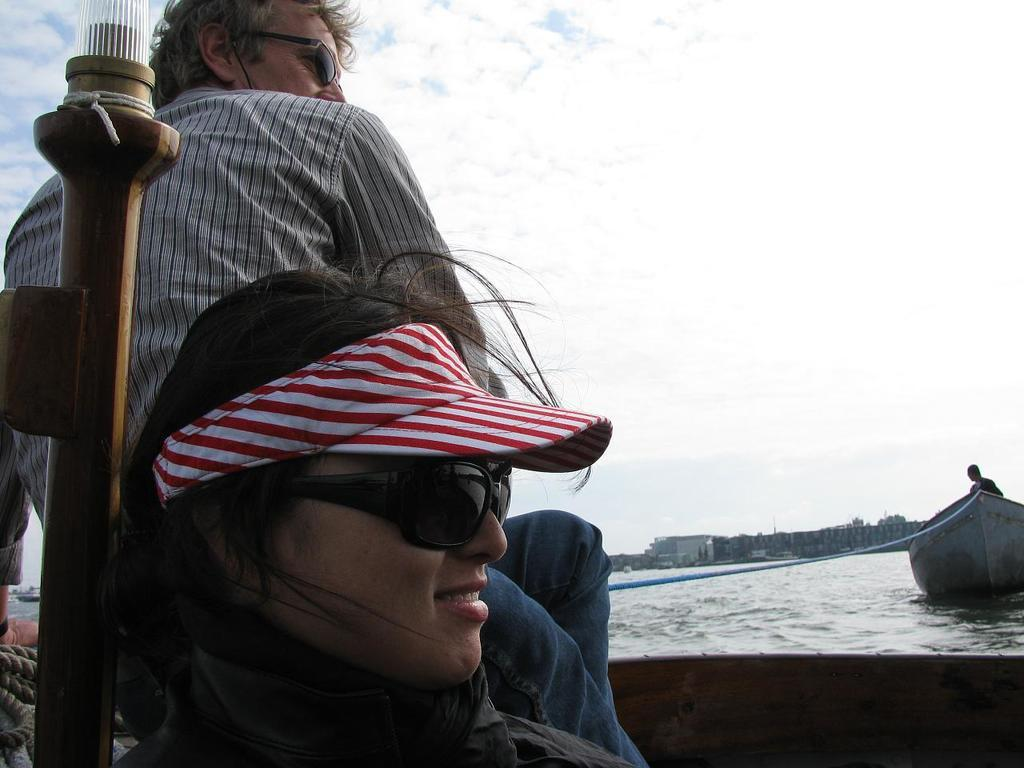What is at the bottom of the image? There is water at the bottom of the image. Who can be seen in the front of the image? There are two persons sitting in the front of the image. What is located on the right side of the image? There is a boat on the right side of the image. What is visible at the top of the image? There is sky visible at the top of the image. What type of cable can be seen connecting the two persons in the image? There is no cable connecting the two persons in the image. Can you describe the patch of land visible in the image? There is no patch of land visible in the image; it features water, a boat, and the sky. 